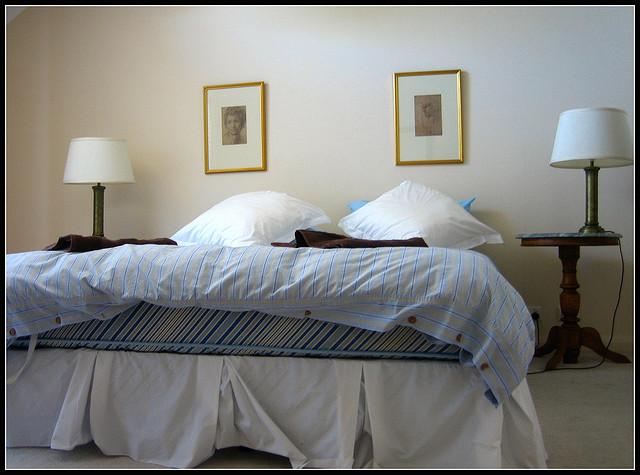How many table lamps do you see?
Give a very brief answer. 2. Is the mattress visible?
Short answer required. Yes. How many pillows are on the bed?
Quick response, please. 3. Is the bed made?
Write a very short answer. Yes. 